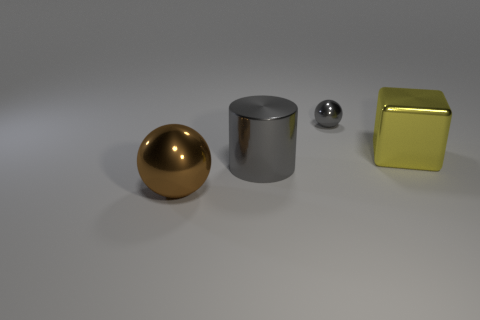Does the big thing on the right side of the small metallic object have the same shape as the gray metallic object that is in front of the tiny object?
Offer a very short reply. No. Are there fewer gray metallic cylinders that are in front of the yellow object than cubes that are in front of the cylinder?
Keep it short and to the point. No. How many other things are there of the same shape as the yellow thing?
Give a very brief answer. 0. The small gray object that is the same material as the yellow object is what shape?
Your response must be concise. Sphere. The shiny thing that is both left of the cube and behind the large cylinder is what color?
Your answer should be compact. Gray. Is the ball in front of the gray cylinder made of the same material as the big yellow object?
Provide a short and direct response. Yes. Are there fewer big gray shiny objects right of the gray ball than brown balls?
Your answer should be very brief. Yes. Is there a tiny purple ball that has the same material as the small object?
Provide a succinct answer. No. There is a yellow shiny block; is it the same size as the gray object in front of the yellow thing?
Your answer should be very brief. Yes. Are there any big blocks that have the same color as the big shiny sphere?
Your answer should be very brief. No. 